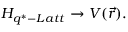Convert formula to latex. <formula><loc_0><loc_0><loc_500><loc_500>H _ { q ^ { \ast } - L a t t } \rightarrow V ( \vec { r } ) .</formula> 